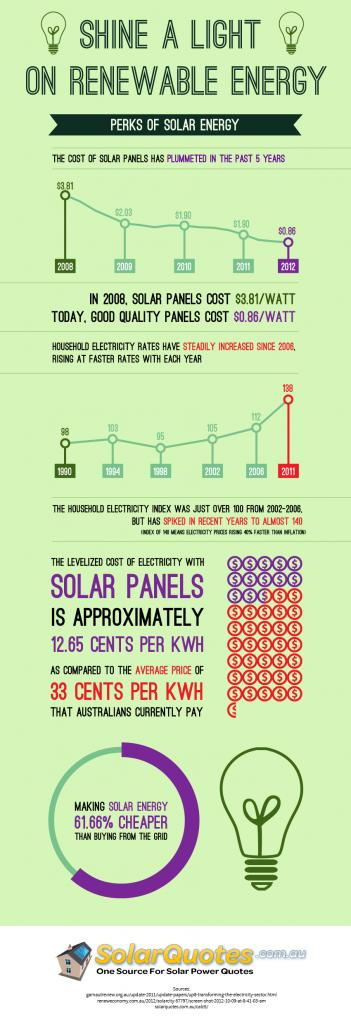Point out several critical features in this image. The household electricity index exceeded 100 in 4 years. The cost difference between solar panels in 2009 and 2010 was $0.13. In two years, the household electricity index is greater than 110. In 2008, the cost of a solar panel was $1.78 less than it was in 2009. In all years from 2010 to 2011, the cost of solar panels remains constant. 